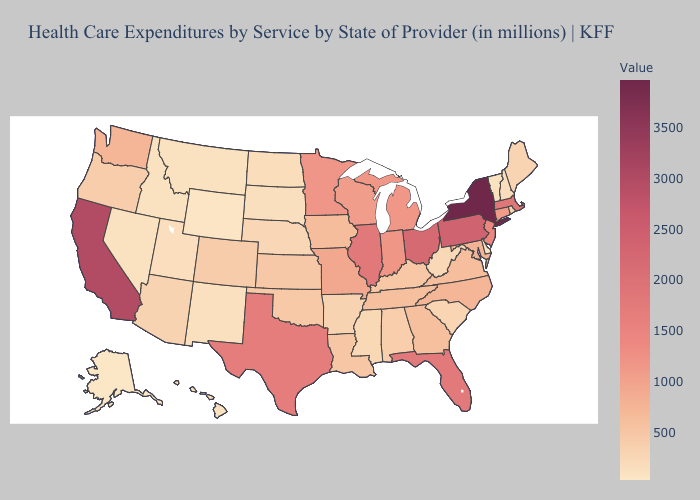Does the map have missing data?
Concise answer only. No. Does Missouri have the highest value in the MidWest?
Answer briefly. No. Does Vermont have the highest value in the Northeast?
Short answer required. No. Among the states that border Michigan , does Indiana have the highest value?
Be succinct. No. Among the states that border North Dakota , which have the highest value?
Short answer required. Minnesota. Which states hav the highest value in the West?
Be succinct. California. 